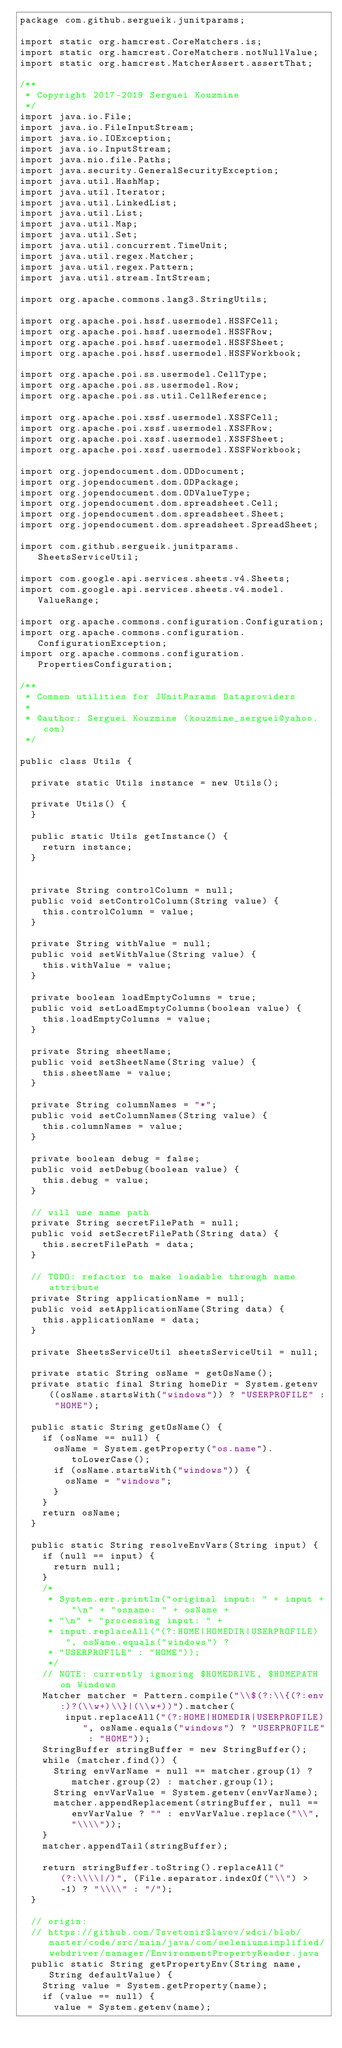Convert code to text. <code><loc_0><loc_0><loc_500><loc_500><_Java_>package com.github.sergueik.junitparams;

import static org.hamcrest.CoreMatchers.is;
import static org.hamcrest.CoreMatchers.notNullValue;
import static org.hamcrest.MatcherAssert.assertThat;

/**
 * Copyright 2017-2019 Serguei Kouzmine
 */
import java.io.File;
import java.io.FileInputStream;
import java.io.IOException;
import java.io.InputStream;
import java.nio.file.Paths;
import java.security.GeneralSecurityException;
import java.util.HashMap;
import java.util.Iterator;
import java.util.LinkedList;
import java.util.List;
import java.util.Map;
import java.util.Set;
import java.util.concurrent.TimeUnit;
import java.util.regex.Matcher;
import java.util.regex.Pattern;
import java.util.stream.IntStream;

import org.apache.commons.lang3.StringUtils;

import org.apache.poi.hssf.usermodel.HSSFCell;
import org.apache.poi.hssf.usermodel.HSSFRow;
import org.apache.poi.hssf.usermodel.HSSFSheet;
import org.apache.poi.hssf.usermodel.HSSFWorkbook;

import org.apache.poi.ss.usermodel.CellType;
import org.apache.poi.ss.usermodel.Row;
import org.apache.poi.ss.util.CellReference;

import org.apache.poi.xssf.usermodel.XSSFCell;
import org.apache.poi.xssf.usermodel.XSSFRow;
import org.apache.poi.xssf.usermodel.XSSFSheet;
import org.apache.poi.xssf.usermodel.XSSFWorkbook;

import org.jopendocument.dom.ODDocument;
import org.jopendocument.dom.ODPackage;
import org.jopendocument.dom.ODValueType;
import org.jopendocument.dom.spreadsheet.Cell;
import org.jopendocument.dom.spreadsheet.Sheet;
import org.jopendocument.dom.spreadsheet.SpreadSheet;

import com.github.sergueik.junitparams.SheetsServiceUtil;

import com.google.api.services.sheets.v4.Sheets;
import com.google.api.services.sheets.v4.model.ValueRange;

import org.apache.commons.configuration.Configuration;
import org.apache.commons.configuration.ConfigurationException;
import org.apache.commons.configuration.PropertiesConfiguration;

/**
 * Common utilities for JUnitParams Dataproviders
 * 
 * @author: Serguei Kouzmine (kouzmine_serguei@yahoo.com)
 */

public class Utils {

	private static Utils instance = new Utils();

	private Utils() {
	}

	public static Utils getInstance() {
		return instance;
	}


	private String controlColumn = null;
	public void setControlColumn(String value) {
		this.controlColumn = value;
	}

	private String withValue = null;
	public void setWithValue(String value) {
		this.withValue = value;
	}

	private boolean loadEmptyColumns = true;
	public void setLoadEmptyColumns(boolean value) {
		this.loadEmptyColumns = value;
	}

	private String sheetName;
	public void setSheetName(String value) {
		this.sheetName = value;
	}

	private String columnNames = "*";
	public void setColumnNames(String value) {
		this.columnNames = value;
	}

	private boolean debug = false;
	public void setDebug(boolean value) {
		this.debug = value;
	}

	// will use name path
	private String secretFilePath = null;
	public void setSecretFilePath(String data) {
		this.secretFilePath = data;
	}

	// TODO: refactor to make loadable through name attribute
	private String applicationName = null;
	public void setApplicationName(String data) {
		this.applicationName = data;
	}

	private SheetsServiceUtil sheetsServiceUtil = null;

	private static String osName = getOsName();
	private static final String homeDir = System.getenv((osName.startsWith("windows")) ? "USERPROFILE" : "HOME");

	public static String getOsName() {
		if (osName == null) {
			osName = System.getProperty("os.name").toLowerCase();
			if (osName.startsWith("windows")) {
				osName = "windows";
			}
		}
		return osName;
	}

	public static String resolveEnvVars(String input) {
		if (null == input) {
			return null;
		}
		/*
		 * System.err.println("original input: " + input + "\n" + "osname: " + osName +
		 * "\n" + "processing input: " +
		 * input.replaceAll("(?:HOME|HOMEDIR|USERPROFILE)", osName.equals("windows") ?
		 * "USERPROFILE" : "HOME"));
		 */
		// NOTE: currently ignoring $HOMEDRIVE, $HOMEPATH on Windows
		Matcher matcher = Pattern.compile("\\$(?:\\{(?:env:)?(\\w+)\\}|(\\w+))").matcher(
				input.replaceAll("(?:HOME|HOMEDIR|USERPROFILE)", osName.equals("windows") ? "USERPROFILE" : "HOME"));
		StringBuffer stringBuffer = new StringBuffer();
		while (matcher.find()) {
			String envVarName = null == matcher.group(1) ? matcher.group(2) : matcher.group(1);
			String envVarValue = System.getenv(envVarName);
			matcher.appendReplacement(stringBuffer, null == envVarValue ? "" : envVarValue.replace("\\", "\\\\"));
		}
		matcher.appendTail(stringBuffer);

		return stringBuffer.toString().replaceAll("(?:\\\\|/)", (File.separator.indexOf("\\") > -1) ? "\\\\" : "/");
	}

	// origin:
	// https://github.com/TsvetomirSlavov/wdci/blob/master/code/src/main/java/com/seleniumsimplified/webdriver/manager/EnvironmentPropertyReader.java
	public static String getPropertyEnv(String name, String defaultValue) {
		String value = System.getProperty(name);
		if (value == null) {
			value = System.getenv(name);</code> 